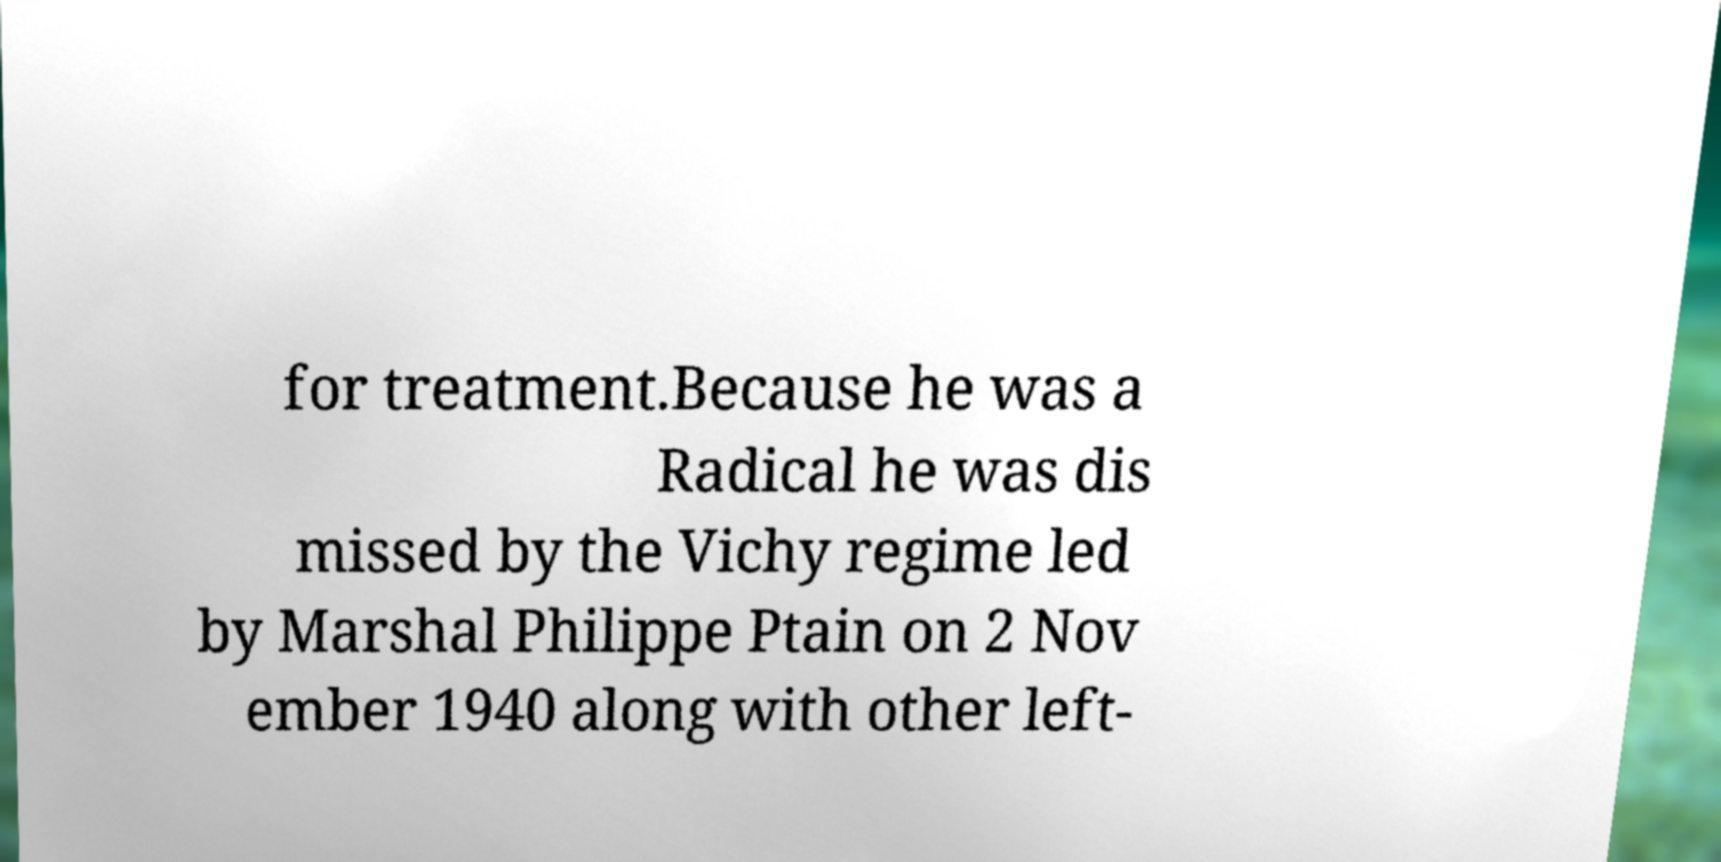There's text embedded in this image that I need extracted. Can you transcribe it verbatim? for treatment.Because he was a Radical he was dis missed by the Vichy regime led by Marshal Philippe Ptain on 2 Nov ember 1940 along with other left- 